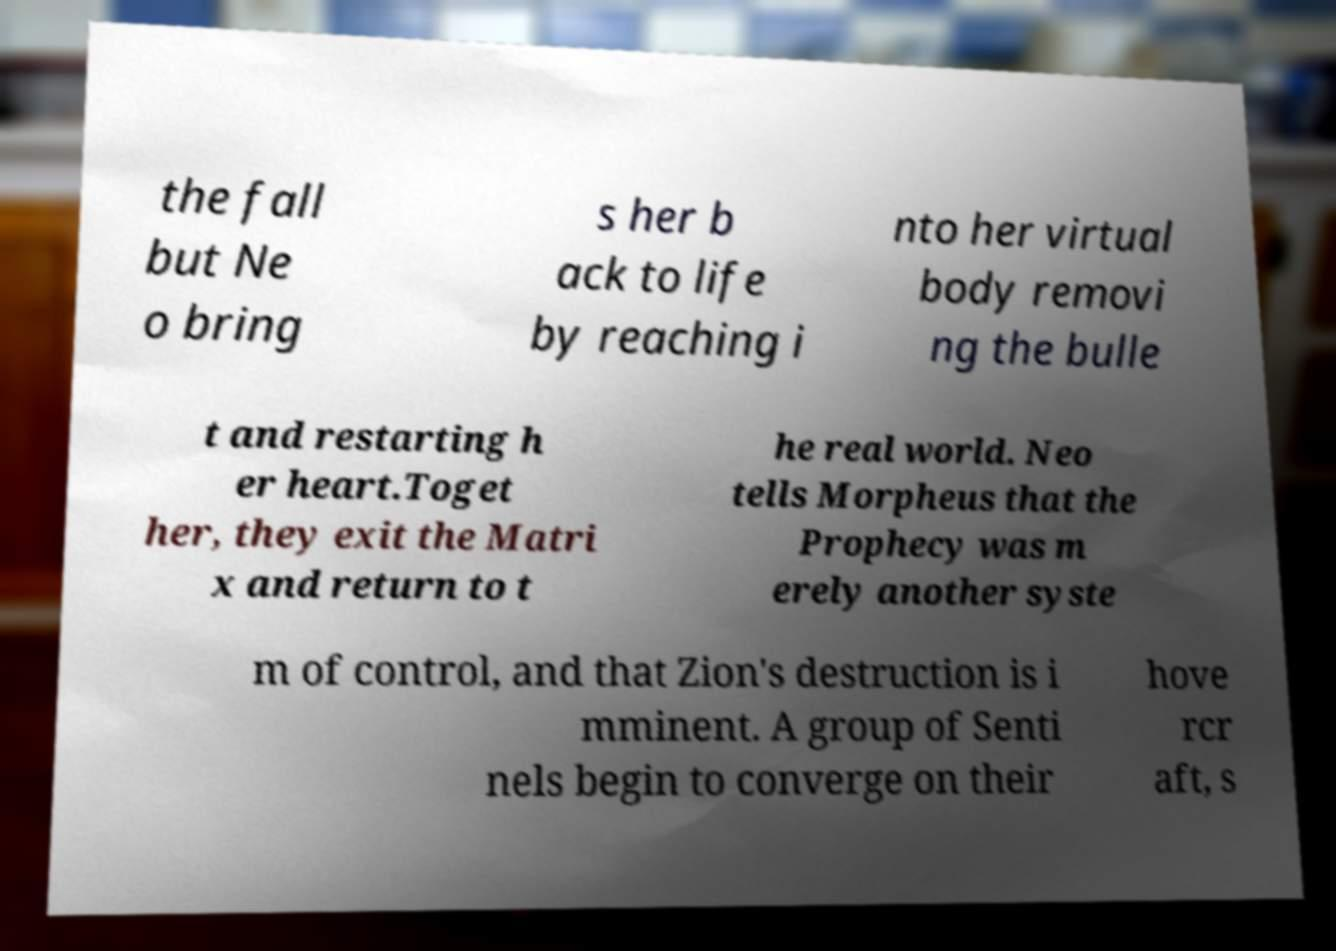What messages or text are displayed in this image? I need them in a readable, typed format. the fall but Ne o bring s her b ack to life by reaching i nto her virtual body removi ng the bulle t and restarting h er heart.Toget her, they exit the Matri x and return to t he real world. Neo tells Morpheus that the Prophecy was m erely another syste m of control, and that Zion's destruction is i mminent. A group of Senti nels begin to converge on their hove rcr aft, s 